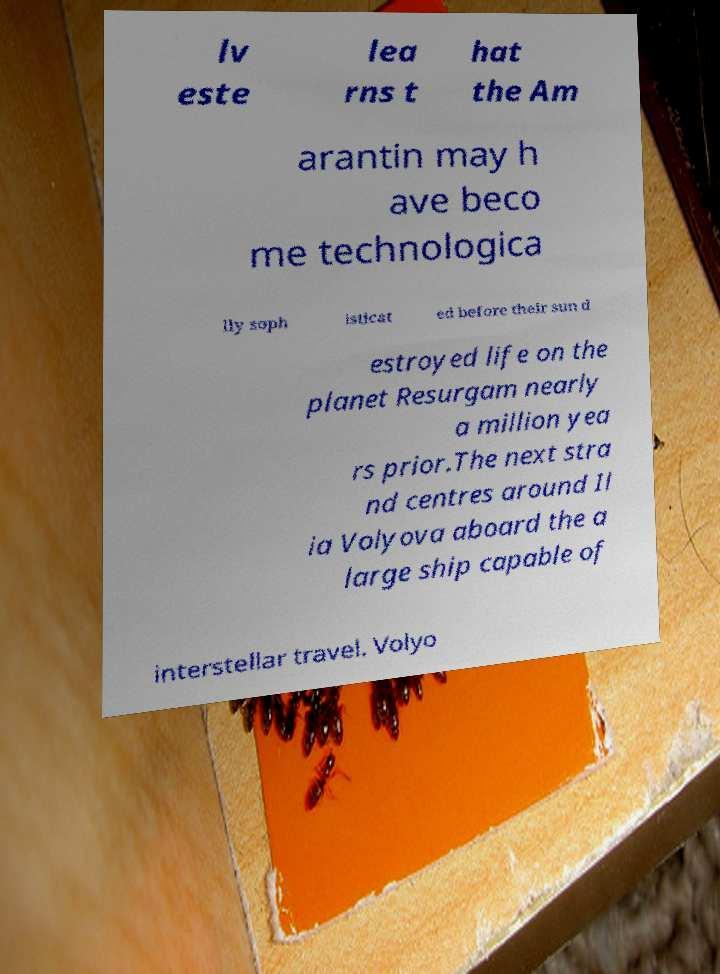Can you accurately transcribe the text from the provided image for me? lv este lea rns t hat the Am arantin may h ave beco me technologica lly soph isticat ed before their sun d estroyed life on the planet Resurgam nearly a million yea rs prior.The next stra nd centres around Il ia Volyova aboard the a large ship capable of interstellar travel. Volyo 